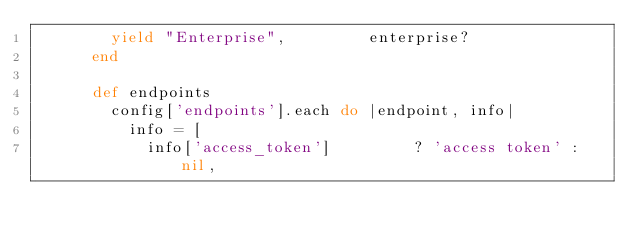<code> <loc_0><loc_0><loc_500><loc_500><_Ruby_>        yield "Enterprise",         enterprise?
      end

      def endpoints
        config['endpoints'].each do |endpoint, info|
          info = [
            info['access_token']         ? 'access token' : nil,</code> 